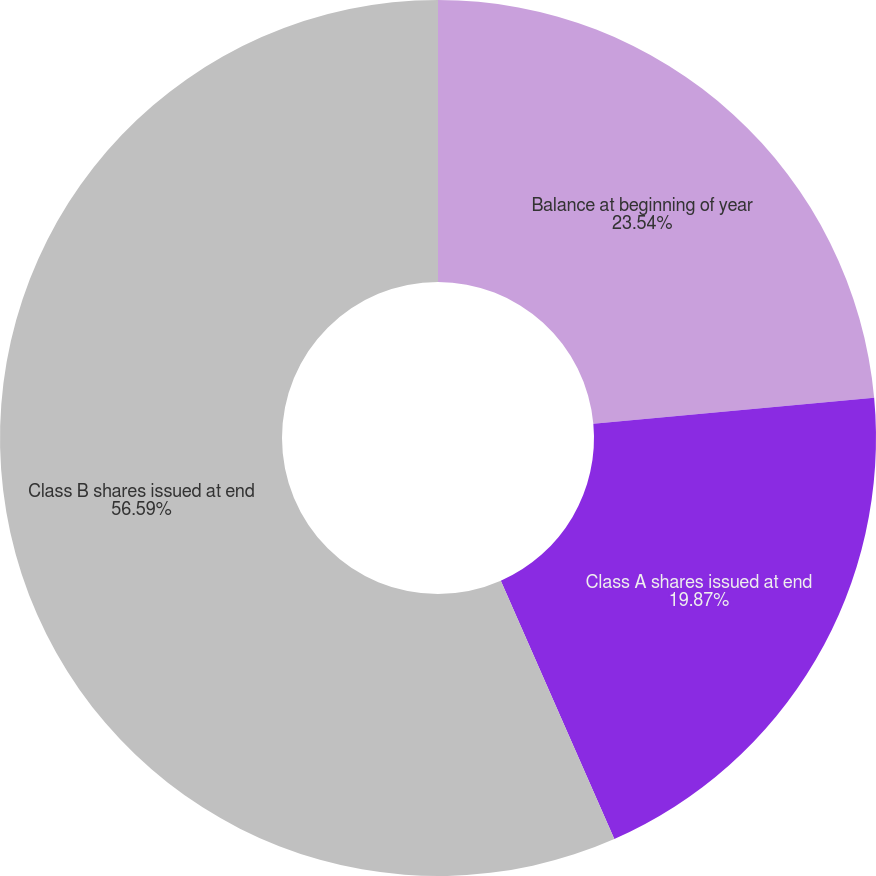Convert chart. <chart><loc_0><loc_0><loc_500><loc_500><pie_chart><fcel>Balance at beginning of year<fcel>Class A shares issued at end<fcel>Class B shares issued at end<nl><fcel>23.54%<fcel>19.87%<fcel>56.6%<nl></chart> 